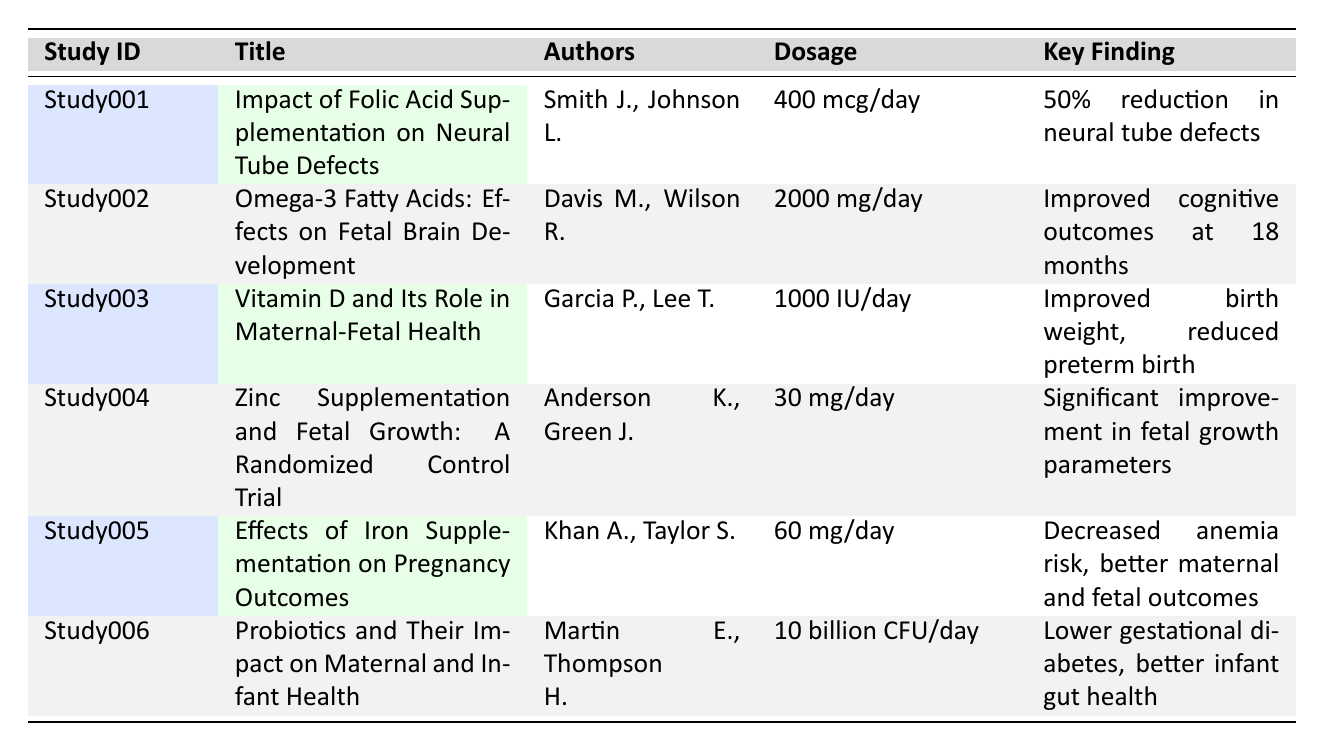What is the title of the study that focuses on folic acid? The title associated with Study001 is "Impact of Folic Acid Supplementation on Neural Tube Defects."
Answer: Impact of Folic Acid Supplementation on Neural Tube Defects Which journal published the study on omega-3 fatty acids? The study titled "Omega-3 Fatty Acids: Effects on Fetal Brain Development" published in the journal "Neuropsychobiology."
Answer: Neuropsychobiology What dosage of zinc was used in the study conducted in Africa? The dosage of zinc used in Study004 is 30 mg/day as indicated in the table.
Answer: 30 mg/day Did any study report a decrease in anemia risk due to supplementation? Yes, the study titled "Effects of Iron Supplementation on Pregnancy Outcomes" reported decreased anemia risk.
Answer: Yes How many authors contributed to the study on probiotics? The study "Probiotics and Their Impact on Maternal and Infant Health" has two authors listed: Martin E. and Thompson H.
Answer: 2 authors Which study had the longest follow-up period? The study with the longest follow-up period is "Omega-3 Fatty Acids: Effects on Fetal Brain Development" with a follow-up of 2 years.
Answer: Omega-3 Fatty Acids: Effects on Fetal Brain Development What is the average dosage of supplements across the studies listed? First, we list the dosages: 400 mcg/day, 2000 mg/day, 1000 IU/day, 30 mg/day, 60 mg/day, and 10 billion CFU/day. We convert them to a common unit (e.g., mg): 0.4 mg + 2000 mg + 1 mg + 30 mg + 60 mg + 10 = 2101.4 mg. There are 6 studies, so the average dosage is 2101.4 mg/6 = 350.23 mg.
Answer: 350.23 mg Which study found a correlation between maternal vitamin D levels and birth outcomes? The study titled "Vitamin D and Its Role in Maternal-Fetal Health" found that higher maternal vitamin D levels correlated with improved birth weight and reduced rates of preterm birth.
Answer: Vitamin D and Its Role in Maternal-Fetal Health How many studies mention improvements related to cognitive outcomes? There are 2 studies that mention improvements related to cognitive outcomes: "Omega-3 Fatty Acids: Effects on Fetal Brain Development" and "Probiotics and Their Impact on Maternal and Infant Health."
Answer: 2 studies Is there any study from 2023 mentioned in the table? Yes, the study titled "Zinc Supplementation and Fetal Growth: A Randomized Control Trial" is from 2023.
Answer: Yes What is the relationship between maternal supplementation and fetal growth according to the studies? The studies show a positive relationship between maternal supplementation and fetal growth, with "Zinc Supplementation and Fetal Growth" reporting significant improvements in fetal growth parameters.
Answer: Positive relationship 